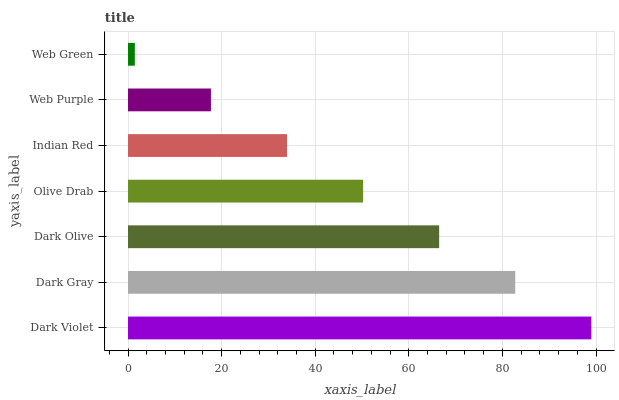Is Web Green the minimum?
Answer yes or no. Yes. Is Dark Violet the maximum?
Answer yes or no. Yes. Is Dark Gray the minimum?
Answer yes or no. No. Is Dark Gray the maximum?
Answer yes or no. No. Is Dark Violet greater than Dark Gray?
Answer yes or no. Yes. Is Dark Gray less than Dark Violet?
Answer yes or no. Yes. Is Dark Gray greater than Dark Violet?
Answer yes or no. No. Is Dark Violet less than Dark Gray?
Answer yes or no. No. Is Olive Drab the high median?
Answer yes or no. Yes. Is Olive Drab the low median?
Answer yes or no. Yes. Is Dark Gray the high median?
Answer yes or no. No. Is Web Purple the low median?
Answer yes or no. No. 